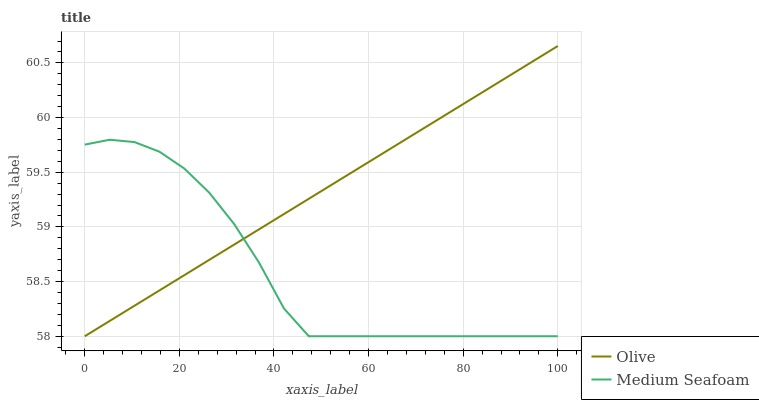Does Medium Seafoam have the minimum area under the curve?
Answer yes or no. Yes. Does Olive have the maximum area under the curve?
Answer yes or no. Yes. Does Medium Seafoam have the maximum area under the curve?
Answer yes or no. No. Is Olive the smoothest?
Answer yes or no. Yes. Is Medium Seafoam the roughest?
Answer yes or no. Yes. Is Medium Seafoam the smoothest?
Answer yes or no. No. Does Olive have the lowest value?
Answer yes or no. Yes. Does Olive have the highest value?
Answer yes or no. Yes. Does Medium Seafoam have the highest value?
Answer yes or no. No. Does Olive intersect Medium Seafoam?
Answer yes or no. Yes. Is Olive less than Medium Seafoam?
Answer yes or no. No. Is Olive greater than Medium Seafoam?
Answer yes or no. No. 